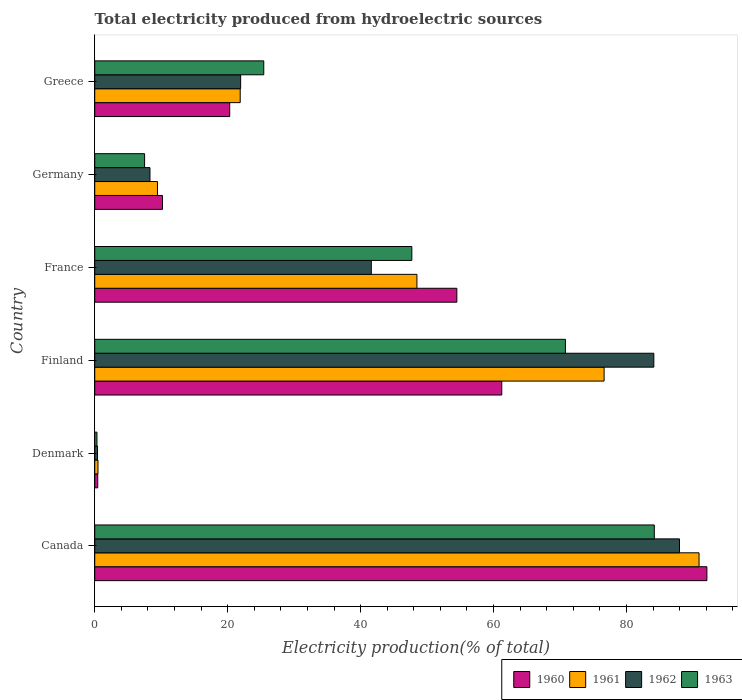How many groups of bars are there?
Keep it short and to the point. 6. Are the number of bars per tick equal to the number of legend labels?
Your answer should be compact. Yes. Are the number of bars on each tick of the Y-axis equal?
Make the answer very short. Yes. How many bars are there on the 2nd tick from the top?
Your response must be concise. 4. How many bars are there on the 1st tick from the bottom?
Give a very brief answer. 4. What is the label of the 1st group of bars from the top?
Provide a succinct answer. Greece. What is the total electricity produced in 1961 in France?
Keep it short and to the point. 48.47. Across all countries, what is the maximum total electricity produced in 1960?
Ensure brevity in your answer.  92.09. Across all countries, what is the minimum total electricity produced in 1962?
Keep it short and to the point. 0.42. In which country was the total electricity produced in 1960 maximum?
Give a very brief answer. Canada. What is the total total electricity produced in 1962 in the graph?
Keep it short and to the point. 244.36. What is the difference between the total electricity produced in 1961 in Denmark and that in Finland?
Provide a succinct answer. -76.14. What is the difference between the total electricity produced in 1962 in Greece and the total electricity produced in 1961 in Canada?
Your answer should be compact. -68.96. What is the average total electricity produced in 1962 per country?
Offer a terse response. 40.73. What is the difference between the total electricity produced in 1963 and total electricity produced in 1961 in Canada?
Your answer should be very brief. -6.73. In how many countries, is the total electricity produced in 1960 greater than 56 %?
Your answer should be compact. 2. What is the ratio of the total electricity produced in 1960 in Germany to that in Greece?
Your response must be concise. 0.5. Is the difference between the total electricity produced in 1963 in France and Germany greater than the difference between the total electricity produced in 1961 in France and Germany?
Ensure brevity in your answer.  Yes. What is the difference between the highest and the second highest total electricity produced in 1961?
Keep it short and to the point. 14.28. What is the difference between the highest and the lowest total electricity produced in 1963?
Offer a terse response. 83.84. What does the 3rd bar from the top in Finland represents?
Keep it short and to the point. 1961. What does the 4th bar from the bottom in France represents?
Keep it short and to the point. 1963. How many bars are there?
Provide a succinct answer. 24. Are all the bars in the graph horizontal?
Your response must be concise. Yes. Are the values on the major ticks of X-axis written in scientific E-notation?
Your answer should be very brief. No. Does the graph contain any zero values?
Make the answer very short. No. Does the graph contain grids?
Your answer should be very brief. No. How many legend labels are there?
Your response must be concise. 4. What is the title of the graph?
Your answer should be very brief. Total electricity produced from hydroelectric sources. What is the label or title of the X-axis?
Your answer should be very brief. Electricity production(% of total). What is the label or title of the Y-axis?
Offer a very short reply. Country. What is the Electricity production(% of total) of 1960 in Canada?
Offer a terse response. 92.09. What is the Electricity production(% of total) of 1961 in Canada?
Ensure brevity in your answer.  90.91. What is the Electricity production(% of total) in 1962 in Canada?
Keep it short and to the point. 87.97. What is the Electricity production(% of total) in 1963 in Canada?
Give a very brief answer. 84.18. What is the Electricity production(% of total) in 1960 in Denmark?
Keep it short and to the point. 0.45. What is the Electricity production(% of total) in 1961 in Denmark?
Ensure brevity in your answer.  0.49. What is the Electricity production(% of total) of 1962 in Denmark?
Ensure brevity in your answer.  0.42. What is the Electricity production(% of total) of 1963 in Denmark?
Provide a succinct answer. 0.33. What is the Electricity production(% of total) of 1960 in Finland?
Make the answer very short. 61.23. What is the Electricity production(% of total) in 1961 in Finland?
Your answer should be compact. 76.63. What is the Electricity production(% of total) in 1962 in Finland?
Keep it short and to the point. 84.11. What is the Electricity production(% of total) in 1963 in Finland?
Make the answer very short. 70.81. What is the Electricity production(% of total) in 1960 in France?
Offer a very short reply. 54.47. What is the Electricity production(% of total) in 1961 in France?
Offer a terse response. 48.47. What is the Electricity production(% of total) in 1962 in France?
Your answer should be compact. 41.61. What is the Electricity production(% of total) of 1963 in France?
Your answer should be very brief. 47.7. What is the Electricity production(% of total) in 1960 in Germany?
Give a very brief answer. 10.19. What is the Electricity production(% of total) in 1961 in Germany?
Offer a terse response. 9.44. What is the Electricity production(% of total) in 1962 in Germany?
Keep it short and to the point. 8.31. What is the Electricity production(% of total) in 1963 in Germany?
Your answer should be very brief. 7.5. What is the Electricity production(% of total) in 1960 in Greece?
Offer a terse response. 20.31. What is the Electricity production(% of total) of 1961 in Greece?
Provide a short and direct response. 21.88. What is the Electricity production(% of total) of 1962 in Greece?
Provide a short and direct response. 21.95. What is the Electricity production(% of total) in 1963 in Greece?
Provide a short and direct response. 25.43. Across all countries, what is the maximum Electricity production(% of total) of 1960?
Your answer should be very brief. 92.09. Across all countries, what is the maximum Electricity production(% of total) of 1961?
Provide a short and direct response. 90.91. Across all countries, what is the maximum Electricity production(% of total) of 1962?
Keep it short and to the point. 87.97. Across all countries, what is the maximum Electricity production(% of total) in 1963?
Provide a short and direct response. 84.18. Across all countries, what is the minimum Electricity production(% of total) in 1960?
Your answer should be very brief. 0.45. Across all countries, what is the minimum Electricity production(% of total) of 1961?
Offer a terse response. 0.49. Across all countries, what is the minimum Electricity production(% of total) in 1962?
Offer a terse response. 0.42. Across all countries, what is the minimum Electricity production(% of total) of 1963?
Your answer should be compact. 0.33. What is the total Electricity production(% of total) of 1960 in the graph?
Offer a very short reply. 238.74. What is the total Electricity production(% of total) in 1961 in the graph?
Give a very brief answer. 247.82. What is the total Electricity production(% of total) in 1962 in the graph?
Give a very brief answer. 244.36. What is the total Electricity production(% of total) in 1963 in the graph?
Offer a terse response. 235.95. What is the difference between the Electricity production(% of total) of 1960 in Canada and that in Denmark?
Ensure brevity in your answer.  91.64. What is the difference between the Electricity production(% of total) in 1961 in Canada and that in Denmark?
Make the answer very short. 90.42. What is the difference between the Electricity production(% of total) of 1962 in Canada and that in Denmark?
Make the answer very short. 87.55. What is the difference between the Electricity production(% of total) in 1963 in Canada and that in Denmark?
Your response must be concise. 83.84. What is the difference between the Electricity production(% of total) of 1960 in Canada and that in Finland?
Provide a short and direct response. 30.86. What is the difference between the Electricity production(% of total) of 1961 in Canada and that in Finland?
Your answer should be compact. 14.28. What is the difference between the Electricity production(% of total) in 1962 in Canada and that in Finland?
Keep it short and to the point. 3.86. What is the difference between the Electricity production(% of total) of 1963 in Canada and that in Finland?
Offer a very short reply. 13.37. What is the difference between the Electricity production(% of total) of 1960 in Canada and that in France?
Your response must be concise. 37.62. What is the difference between the Electricity production(% of total) in 1961 in Canada and that in France?
Make the answer very short. 42.44. What is the difference between the Electricity production(% of total) in 1962 in Canada and that in France?
Provide a short and direct response. 46.36. What is the difference between the Electricity production(% of total) of 1963 in Canada and that in France?
Make the answer very short. 36.48. What is the difference between the Electricity production(% of total) of 1960 in Canada and that in Germany?
Keep it short and to the point. 81.9. What is the difference between the Electricity production(% of total) of 1961 in Canada and that in Germany?
Keep it short and to the point. 81.47. What is the difference between the Electricity production(% of total) in 1962 in Canada and that in Germany?
Keep it short and to the point. 79.66. What is the difference between the Electricity production(% of total) of 1963 in Canada and that in Germany?
Your answer should be very brief. 76.68. What is the difference between the Electricity production(% of total) in 1960 in Canada and that in Greece?
Give a very brief answer. 71.78. What is the difference between the Electricity production(% of total) in 1961 in Canada and that in Greece?
Provide a short and direct response. 69.03. What is the difference between the Electricity production(% of total) in 1962 in Canada and that in Greece?
Give a very brief answer. 66.02. What is the difference between the Electricity production(% of total) in 1963 in Canada and that in Greece?
Offer a terse response. 58.75. What is the difference between the Electricity production(% of total) of 1960 in Denmark and that in Finland?
Offer a terse response. -60.78. What is the difference between the Electricity production(% of total) of 1961 in Denmark and that in Finland?
Give a very brief answer. -76.14. What is the difference between the Electricity production(% of total) of 1962 in Denmark and that in Finland?
Provide a short and direct response. -83.69. What is the difference between the Electricity production(% of total) of 1963 in Denmark and that in Finland?
Your answer should be very brief. -70.47. What is the difference between the Electricity production(% of total) in 1960 in Denmark and that in France?
Make the answer very short. -54.02. What is the difference between the Electricity production(% of total) in 1961 in Denmark and that in France?
Ensure brevity in your answer.  -47.98. What is the difference between the Electricity production(% of total) of 1962 in Denmark and that in France?
Offer a very short reply. -41.18. What is the difference between the Electricity production(% of total) in 1963 in Denmark and that in France?
Provide a succinct answer. -47.37. What is the difference between the Electricity production(% of total) in 1960 in Denmark and that in Germany?
Your response must be concise. -9.74. What is the difference between the Electricity production(% of total) in 1961 in Denmark and that in Germany?
Offer a terse response. -8.95. What is the difference between the Electricity production(% of total) of 1962 in Denmark and that in Germany?
Provide a succinct answer. -7.89. What is the difference between the Electricity production(% of total) of 1963 in Denmark and that in Germany?
Provide a short and direct response. -7.17. What is the difference between the Electricity production(% of total) of 1960 in Denmark and that in Greece?
Provide a succinct answer. -19.85. What is the difference between the Electricity production(% of total) of 1961 in Denmark and that in Greece?
Offer a terse response. -21.39. What is the difference between the Electricity production(% of total) in 1962 in Denmark and that in Greece?
Ensure brevity in your answer.  -21.53. What is the difference between the Electricity production(% of total) in 1963 in Denmark and that in Greece?
Offer a terse response. -25.09. What is the difference between the Electricity production(% of total) of 1960 in Finland and that in France?
Your response must be concise. 6.76. What is the difference between the Electricity production(% of total) of 1961 in Finland and that in France?
Your answer should be compact. 28.16. What is the difference between the Electricity production(% of total) of 1962 in Finland and that in France?
Offer a very short reply. 42.5. What is the difference between the Electricity production(% of total) of 1963 in Finland and that in France?
Offer a very short reply. 23.11. What is the difference between the Electricity production(% of total) in 1960 in Finland and that in Germany?
Ensure brevity in your answer.  51.04. What is the difference between the Electricity production(% of total) in 1961 in Finland and that in Germany?
Provide a succinct answer. 67.19. What is the difference between the Electricity production(% of total) of 1962 in Finland and that in Germany?
Provide a short and direct response. 75.8. What is the difference between the Electricity production(% of total) in 1963 in Finland and that in Germany?
Your response must be concise. 63.31. What is the difference between the Electricity production(% of total) of 1960 in Finland and that in Greece?
Provide a succinct answer. 40.93. What is the difference between the Electricity production(% of total) in 1961 in Finland and that in Greece?
Offer a very short reply. 54.75. What is the difference between the Electricity production(% of total) of 1962 in Finland and that in Greece?
Offer a very short reply. 62.16. What is the difference between the Electricity production(% of total) in 1963 in Finland and that in Greece?
Your answer should be very brief. 45.38. What is the difference between the Electricity production(% of total) in 1960 in France and that in Germany?
Offer a very short reply. 44.28. What is the difference between the Electricity production(% of total) in 1961 in France and that in Germany?
Your answer should be very brief. 39.03. What is the difference between the Electricity production(% of total) of 1962 in France and that in Germany?
Give a very brief answer. 33.3. What is the difference between the Electricity production(% of total) in 1963 in France and that in Germany?
Your response must be concise. 40.2. What is the difference between the Electricity production(% of total) in 1960 in France and that in Greece?
Give a very brief answer. 34.17. What is the difference between the Electricity production(% of total) in 1961 in France and that in Greece?
Provide a succinct answer. 26.58. What is the difference between the Electricity production(% of total) in 1962 in France and that in Greece?
Offer a very short reply. 19.66. What is the difference between the Electricity production(% of total) of 1963 in France and that in Greece?
Ensure brevity in your answer.  22.27. What is the difference between the Electricity production(% of total) of 1960 in Germany and that in Greece?
Give a very brief answer. -10.11. What is the difference between the Electricity production(% of total) in 1961 in Germany and that in Greece?
Ensure brevity in your answer.  -12.45. What is the difference between the Electricity production(% of total) in 1962 in Germany and that in Greece?
Your answer should be very brief. -13.64. What is the difference between the Electricity production(% of total) of 1963 in Germany and that in Greece?
Make the answer very short. -17.93. What is the difference between the Electricity production(% of total) of 1960 in Canada and the Electricity production(% of total) of 1961 in Denmark?
Your response must be concise. 91.6. What is the difference between the Electricity production(% of total) of 1960 in Canada and the Electricity production(% of total) of 1962 in Denmark?
Offer a very short reply. 91.67. What is the difference between the Electricity production(% of total) of 1960 in Canada and the Electricity production(% of total) of 1963 in Denmark?
Your answer should be compact. 91.75. What is the difference between the Electricity production(% of total) of 1961 in Canada and the Electricity production(% of total) of 1962 in Denmark?
Offer a very short reply. 90.49. What is the difference between the Electricity production(% of total) of 1961 in Canada and the Electricity production(% of total) of 1963 in Denmark?
Ensure brevity in your answer.  90.58. What is the difference between the Electricity production(% of total) in 1962 in Canada and the Electricity production(% of total) in 1963 in Denmark?
Offer a very short reply. 87.63. What is the difference between the Electricity production(% of total) of 1960 in Canada and the Electricity production(% of total) of 1961 in Finland?
Offer a very short reply. 15.46. What is the difference between the Electricity production(% of total) in 1960 in Canada and the Electricity production(% of total) in 1962 in Finland?
Make the answer very short. 7.98. What is the difference between the Electricity production(% of total) of 1960 in Canada and the Electricity production(% of total) of 1963 in Finland?
Provide a short and direct response. 21.28. What is the difference between the Electricity production(% of total) of 1961 in Canada and the Electricity production(% of total) of 1962 in Finland?
Provide a short and direct response. 6.8. What is the difference between the Electricity production(% of total) of 1961 in Canada and the Electricity production(% of total) of 1963 in Finland?
Your answer should be very brief. 20.1. What is the difference between the Electricity production(% of total) in 1962 in Canada and the Electricity production(% of total) in 1963 in Finland?
Offer a very short reply. 17.16. What is the difference between the Electricity production(% of total) in 1960 in Canada and the Electricity production(% of total) in 1961 in France?
Your answer should be very brief. 43.62. What is the difference between the Electricity production(% of total) of 1960 in Canada and the Electricity production(% of total) of 1962 in France?
Provide a short and direct response. 50.48. What is the difference between the Electricity production(% of total) in 1960 in Canada and the Electricity production(% of total) in 1963 in France?
Provide a succinct answer. 44.39. What is the difference between the Electricity production(% of total) in 1961 in Canada and the Electricity production(% of total) in 1962 in France?
Offer a very short reply. 49.3. What is the difference between the Electricity production(% of total) of 1961 in Canada and the Electricity production(% of total) of 1963 in France?
Offer a terse response. 43.21. What is the difference between the Electricity production(% of total) in 1962 in Canada and the Electricity production(% of total) in 1963 in France?
Ensure brevity in your answer.  40.27. What is the difference between the Electricity production(% of total) of 1960 in Canada and the Electricity production(% of total) of 1961 in Germany?
Provide a short and direct response. 82.65. What is the difference between the Electricity production(% of total) in 1960 in Canada and the Electricity production(% of total) in 1962 in Germany?
Offer a very short reply. 83.78. What is the difference between the Electricity production(% of total) of 1960 in Canada and the Electricity production(% of total) of 1963 in Germany?
Make the answer very short. 84.59. What is the difference between the Electricity production(% of total) of 1961 in Canada and the Electricity production(% of total) of 1962 in Germany?
Your response must be concise. 82.6. What is the difference between the Electricity production(% of total) of 1961 in Canada and the Electricity production(% of total) of 1963 in Germany?
Offer a very short reply. 83.41. What is the difference between the Electricity production(% of total) of 1962 in Canada and the Electricity production(% of total) of 1963 in Germany?
Offer a very short reply. 80.47. What is the difference between the Electricity production(% of total) of 1960 in Canada and the Electricity production(% of total) of 1961 in Greece?
Make the answer very short. 70.21. What is the difference between the Electricity production(% of total) of 1960 in Canada and the Electricity production(% of total) of 1962 in Greece?
Your answer should be very brief. 70.14. What is the difference between the Electricity production(% of total) in 1960 in Canada and the Electricity production(% of total) in 1963 in Greece?
Give a very brief answer. 66.66. What is the difference between the Electricity production(% of total) of 1961 in Canada and the Electricity production(% of total) of 1962 in Greece?
Your answer should be very brief. 68.96. What is the difference between the Electricity production(% of total) in 1961 in Canada and the Electricity production(% of total) in 1963 in Greece?
Provide a succinct answer. 65.48. What is the difference between the Electricity production(% of total) in 1962 in Canada and the Electricity production(% of total) in 1963 in Greece?
Provide a succinct answer. 62.54. What is the difference between the Electricity production(% of total) in 1960 in Denmark and the Electricity production(% of total) in 1961 in Finland?
Keep it short and to the point. -76.18. What is the difference between the Electricity production(% of total) of 1960 in Denmark and the Electricity production(% of total) of 1962 in Finland?
Give a very brief answer. -83.66. What is the difference between the Electricity production(% of total) of 1960 in Denmark and the Electricity production(% of total) of 1963 in Finland?
Ensure brevity in your answer.  -70.36. What is the difference between the Electricity production(% of total) in 1961 in Denmark and the Electricity production(% of total) in 1962 in Finland?
Your response must be concise. -83.62. What is the difference between the Electricity production(% of total) in 1961 in Denmark and the Electricity production(% of total) in 1963 in Finland?
Keep it short and to the point. -70.32. What is the difference between the Electricity production(% of total) in 1962 in Denmark and the Electricity production(% of total) in 1963 in Finland?
Ensure brevity in your answer.  -70.39. What is the difference between the Electricity production(% of total) in 1960 in Denmark and the Electricity production(% of total) in 1961 in France?
Your response must be concise. -48.02. What is the difference between the Electricity production(% of total) of 1960 in Denmark and the Electricity production(% of total) of 1962 in France?
Your answer should be very brief. -41.15. What is the difference between the Electricity production(% of total) of 1960 in Denmark and the Electricity production(% of total) of 1963 in France?
Ensure brevity in your answer.  -47.25. What is the difference between the Electricity production(% of total) in 1961 in Denmark and the Electricity production(% of total) in 1962 in France?
Provide a short and direct response. -41.12. What is the difference between the Electricity production(% of total) in 1961 in Denmark and the Electricity production(% of total) in 1963 in France?
Keep it short and to the point. -47.21. What is the difference between the Electricity production(% of total) of 1962 in Denmark and the Electricity production(% of total) of 1963 in France?
Make the answer very short. -47.28. What is the difference between the Electricity production(% of total) in 1960 in Denmark and the Electricity production(% of total) in 1961 in Germany?
Provide a succinct answer. -8.99. What is the difference between the Electricity production(% of total) in 1960 in Denmark and the Electricity production(% of total) in 1962 in Germany?
Keep it short and to the point. -7.86. What is the difference between the Electricity production(% of total) of 1960 in Denmark and the Electricity production(% of total) of 1963 in Germany?
Give a very brief answer. -7.05. What is the difference between the Electricity production(% of total) in 1961 in Denmark and the Electricity production(% of total) in 1962 in Germany?
Ensure brevity in your answer.  -7.82. What is the difference between the Electricity production(% of total) in 1961 in Denmark and the Electricity production(% of total) in 1963 in Germany?
Provide a short and direct response. -7.01. What is the difference between the Electricity production(% of total) in 1962 in Denmark and the Electricity production(% of total) in 1963 in Germany?
Provide a short and direct response. -7.08. What is the difference between the Electricity production(% of total) of 1960 in Denmark and the Electricity production(% of total) of 1961 in Greece?
Provide a short and direct response. -21.43. What is the difference between the Electricity production(% of total) in 1960 in Denmark and the Electricity production(% of total) in 1962 in Greece?
Offer a terse response. -21.5. What is the difference between the Electricity production(% of total) in 1960 in Denmark and the Electricity production(% of total) in 1963 in Greece?
Provide a succinct answer. -24.98. What is the difference between the Electricity production(% of total) in 1961 in Denmark and the Electricity production(% of total) in 1962 in Greece?
Offer a very short reply. -21.46. What is the difference between the Electricity production(% of total) in 1961 in Denmark and the Electricity production(% of total) in 1963 in Greece?
Your answer should be very brief. -24.94. What is the difference between the Electricity production(% of total) in 1962 in Denmark and the Electricity production(% of total) in 1963 in Greece?
Offer a terse response. -25.01. What is the difference between the Electricity production(% of total) in 1960 in Finland and the Electricity production(% of total) in 1961 in France?
Provide a short and direct response. 12.76. What is the difference between the Electricity production(% of total) in 1960 in Finland and the Electricity production(% of total) in 1962 in France?
Keep it short and to the point. 19.63. What is the difference between the Electricity production(% of total) in 1960 in Finland and the Electricity production(% of total) in 1963 in France?
Offer a very short reply. 13.53. What is the difference between the Electricity production(% of total) in 1961 in Finland and the Electricity production(% of total) in 1962 in France?
Offer a terse response. 35.02. What is the difference between the Electricity production(% of total) of 1961 in Finland and the Electricity production(% of total) of 1963 in France?
Make the answer very short. 28.93. What is the difference between the Electricity production(% of total) in 1962 in Finland and the Electricity production(% of total) in 1963 in France?
Provide a short and direct response. 36.41. What is the difference between the Electricity production(% of total) in 1960 in Finland and the Electricity production(% of total) in 1961 in Germany?
Your answer should be very brief. 51.8. What is the difference between the Electricity production(% of total) in 1960 in Finland and the Electricity production(% of total) in 1962 in Germany?
Your response must be concise. 52.92. What is the difference between the Electricity production(% of total) in 1960 in Finland and the Electricity production(% of total) in 1963 in Germany?
Keep it short and to the point. 53.73. What is the difference between the Electricity production(% of total) in 1961 in Finland and the Electricity production(% of total) in 1962 in Germany?
Keep it short and to the point. 68.32. What is the difference between the Electricity production(% of total) of 1961 in Finland and the Electricity production(% of total) of 1963 in Germany?
Your answer should be very brief. 69.13. What is the difference between the Electricity production(% of total) of 1962 in Finland and the Electricity production(% of total) of 1963 in Germany?
Offer a terse response. 76.61. What is the difference between the Electricity production(% of total) of 1960 in Finland and the Electricity production(% of total) of 1961 in Greece?
Offer a terse response. 39.35. What is the difference between the Electricity production(% of total) in 1960 in Finland and the Electricity production(% of total) in 1962 in Greece?
Keep it short and to the point. 39.28. What is the difference between the Electricity production(% of total) of 1960 in Finland and the Electricity production(% of total) of 1963 in Greece?
Keep it short and to the point. 35.8. What is the difference between the Electricity production(% of total) in 1961 in Finland and the Electricity production(% of total) in 1962 in Greece?
Your answer should be very brief. 54.68. What is the difference between the Electricity production(% of total) of 1961 in Finland and the Electricity production(% of total) of 1963 in Greece?
Your answer should be compact. 51.2. What is the difference between the Electricity production(% of total) in 1962 in Finland and the Electricity production(% of total) in 1963 in Greece?
Provide a succinct answer. 58.68. What is the difference between the Electricity production(% of total) of 1960 in France and the Electricity production(% of total) of 1961 in Germany?
Provide a succinct answer. 45.04. What is the difference between the Electricity production(% of total) in 1960 in France and the Electricity production(% of total) in 1962 in Germany?
Your answer should be compact. 46.16. What is the difference between the Electricity production(% of total) in 1960 in France and the Electricity production(% of total) in 1963 in Germany?
Your answer should be very brief. 46.97. What is the difference between the Electricity production(% of total) of 1961 in France and the Electricity production(% of total) of 1962 in Germany?
Ensure brevity in your answer.  40.16. What is the difference between the Electricity production(% of total) in 1961 in France and the Electricity production(% of total) in 1963 in Germany?
Ensure brevity in your answer.  40.97. What is the difference between the Electricity production(% of total) of 1962 in France and the Electricity production(% of total) of 1963 in Germany?
Offer a very short reply. 34.11. What is the difference between the Electricity production(% of total) of 1960 in France and the Electricity production(% of total) of 1961 in Greece?
Provide a short and direct response. 32.59. What is the difference between the Electricity production(% of total) in 1960 in France and the Electricity production(% of total) in 1962 in Greece?
Offer a terse response. 32.52. What is the difference between the Electricity production(% of total) in 1960 in France and the Electricity production(% of total) in 1963 in Greece?
Offer a terse response. 29.05. What is the difference between the Electricity production(% of total) of 1961 in France and the Electricity production(% of total) of 1962 in Greece?
Keep it short and to the point. 26.52. What is the difference between the Electricity production(% of total) in 1961 in France and the Electricity production(% of total) in 1963 in Greece?
Make the answer very short. 23.04. What is the difference between the Electricity production(% of total) of 1962 in France and the Electricity production(% of total) of 1963 in Greece?
Offer a very short reply. 16.18. What is the difference between the Electricity production(% of total) in 1960 in Germany and the Electricity production(% of total) in 1961 in Greece?
Your answer should be very brief. -11.69. What is the difference between the Electricity production(% of total) in 1960 in Germany and the Electricity production(% of total) in 1962 in Greece?
Your response must be concise. -11.76. What is the difference between the Electricity production(% of total) of 1960 in Germany and the Electricity production(% of total) of 1963 in Greece?
Your response must be concise. -15.24. What is the difference between the Electricity production(% of total) in 1961 in Germany and the Electricity production(% of total) in 1962 in Greece?
Offer a very short reply. -12.51. What is the difference between the Electricity production(% of total) of 1961 in Germany and the Electricity production(% of total) of 1963 in Greece?
Your answer should be very brief. -15.99. What is the difference between the Electricity production(% of total) of 1962 in Germany and the Electricity production(% of total) of 1963 in Greece?
Your answer should be very brief. -17.12. What is the average Electricity production(% of total) in 1960 per country?
Make the answer very short. 39.79. What is the average Electricity production(% of total) in 1961 per country?
Provide a short and direct response. 41.3. What is the average Electricity production(% of total) of 1962 per country?
Provide a succinct answer. 40.73. What is the average Electricity production(% of total) of 1963 per country?
Offer a terse response. 39.33. What is the difference between the Electricity production(% of total) of 1960 and Electricity production(% of total) of 1961 in Canada?
Provide a succinct answer. 1.18. What is the difference between the Electricity production(% of total) of 1960 and Electricity production(% of total) of 1962 in Canada?
Offer a terse response. 4.12. What is the difference between the Electricity production(% of total) in 1960 and Electricity production(% of total) in 1963 in Canada?
Make the answer very short. 7.91. What is the difference between the Electricity production(% of total) in 1961 and Electricity production(% of total) in 1962 in Canada?
Ensure brevity in your answer.  2.94. What is the difference between the Electricity production(% of total) in 1961 and Electricity production(% of total) in 1963 in Canada?
Your answer should be compact. 6.73. What is the difference between the Electricity production(% of total) in 1962 and Electricity production(% of total) in 1963 in Canada?
Ensure brevity in your answer.  3.79. What is the difference between the Electricity production(% of total) of 1960 and Electricity production(% of total) of 1961 in Denmark?
Give a very brief answer. -0.04. What is the difference between the Electricity production(% of total) in 1960 and Electricity production(% of total) in 1962 in Denmark?
Ensure brevity in your answer.  0.03. What is the difference between the Electricity production(% of total) in 1960 and Electricity production(% of total) in 1963 in Denmark?
Offer a very short reply. 0.12. What is the difference between the Electricity production(% of total) in 1961 and Electricity production(% of total) in 1962 in Denmark?
Give a very brief answer. 0.07. What is the difference between the Electricity production(% of total) of 1961 and Electricity production(% of total) of 1963 in Denmark?
Offer a very short reply. 0.15. What is the difference between the Electricity production(% of total) of 1962 and Electricity production(% of total) of 1963 in Denmark?
Make the answer very short. 0.09. What is the difference between the Electricity production(% of total) in 1960 and Electricity production(% of total) in 1961 in Finland?
Ensure brevity in your answer.  -15.4. What is the difference between the Electricity production(% of total) of 1960 and Electricity production(% of total) of 1962 in Finland?
Your answer should be very brief. -22.88. What is the difference between the Electricity production(% of total) of 1960 and Electricity production(% of total) of 1963 in Finland?
Ensure brevity in your answer.  -9.58. What is the difference between the Electricity production(% of total) of 1961 and Electricity production(% of total) of 1962 in Finland?
Offer a very short reply. -7.48. What is the difference between the Electricity production(% of total) in 1961 and Electricity production(% of total) in 1963 in Finland?
Give a very brief answer. 5.82. What is the difference between the Electricity production(% of total) of 1962 and Electricity production(% of total) of 1963 in Finland?
Offer a very short reply. 13.3. What is the difference between the Electricity production(% of total) in 1960 and Electricity production(% of total) in 1961 in France?
Offer a terse response. 6.01. What is the difference between the Electricity production(% of total) in 1960 and Electricity production(% of total) in 1962 in France?
Provide a short and direct response. 12.87. What is the difference between the Electricity production(% of total) in 1960 and Electricity production(% of total) in 1963 in France?
Your response must be concise. 6.77. What is the difference between the Electricity production(% of total) of 1961 and Electricity production(% of total) of 1962 in France?
Ensure brevity in your answer.  6.86. What is the difference between the Electricity production(% of total) of 1961 and Electricity production(% of total) of 1963 in France?
Keep it short and to the point. 0.77. What is the difference between the Electricity production(% of total) in 1962 and Electricity production(% of total) in 1963 in France?
Give a very brief answer. -6.1. What is the difference between the Electricity production(% of total) of 1960 and Electricity production(% of total) of 1961 in Germany?
Your answer should be very brief. 0.76. What is the difference between the Electricity production(% of total) in 1960 and Electricity production(% of total) in 1962 in Germany?
Offer a terse response. 1.88. What is the difference between the Electricity production(% of total) in 1960 and Electricity production(% of total) in 1963 in Germany?
Keep it short and to the point. 2.69. What is the difference between the Electricity production(% of total) of 1961 and Electricity production(% of total) of 1962 in Germany?
Give a very brief answer. 1.13. What is the difference between the Electricity production(% of total) of 1961 and Electricity production(% of total) of 1963 in Germany?
Make the answer very short. 1.94. What is the difference between the Electricity production(% of total) in 1962 and Electricity production(% of total) in 1963 in Germany?
Provide a succinct answer. 0.81. What is the difference between the Electricity production(% of total) of 1960 and Electricity production(% of total) of 1961 in Greece?
Give a very brief answer. -1.58. What is the difference between the Electricity production(% of total) of 1960 and Electricity production(% of total) of 1962 in Greece?
Keep it short and to the point. -1.64. What is the difference between the Electricity production(% of total) in 1960 and Electricity production(% of total) in 1963 in Greece?
Your response must be concise. -5.12. What is the difference between the Electricity production(% of total) of 1961 and Electricity production(% of total) of 1962 in Greece?
Give a very brief answer. -0.07. What is the difference between the Electricity production(% of total) of 1961 and Electricity production(% of total) of 1963 in Greece?
Provide a succinct answer. -3.54. What is the difference between the Electricity production(% of total) in 1962 and Electricity production(% of total) in 1963 in Greece?
Keep it short and to the point. -3.48. What is the ratio of the Electricity production(% of total) in 1960 in Canada to that in Denmark?
Provide a succinct answer. 204.07. What is the ratio of the Electricity production(% of total) in 1961 in Canada to that in Denmark?
Make the answer very short. 185.88. What is the ratio of the Electricity production(% of total) in 1962 in Canada to that in Denmark?
Offer a terse response. 208.99. What is the ratio of the Electricity production(% of total) in 1963 in Canada to that in Denmark?
Your answer should be compact. 251.69. What is the ratio of the Electricity production(% of total) of 1960 in Canada to that in Finland?
Ensure brevity in your answer.  1.5. What is the ratio of the Electricity production(% of total) in 1961 in Canada to that in Finland?
Your answer should be compact. 1.19. What is the ratio of the Electricity production(% of total) of 1962 in Canada to that in Finland?
Provide a succinct answer. 1.05. What is the ratio of the Electricity production(% of total) of 1963 in Canada to that in Finland?
Provide a short and direct response. 1.19. What is the ratio of the Electricity production(% of total) of 1960 in Canada to that in France?
Ensure brevity in your answer.  1.69. What is the ratio of the Electricity production(% of total) of 1961 in Canada to that in France?
Your response must be concise. 1.88. What is the ratio of the Electricity production(% of total) of 1962 in Canada to that in France?
Keep it short and to the point. 2.11. What is the ratio of the Electricity production(% of total) of 1963 in Canada to that in France?
Your response must be concise. 1.76. What is the ratio of the Electricity production(% of total) of 1960 in Canada to that in Germany?
Keep it short and to the point. 9.04. What is the ratio of the Electricity production(% of total) in 1961 in Canada to that in Germany?
Give a very brief answer. 9.63. What is the ratio of the Electricity production(% of total) in 1962 in Canada to that in Germany?
Keep it short and to the point. 10.59. What is the ratio of the Electricity production(% of total) of 1963 in Canada to that in Germany?
Give a very brief answer. 11.22. What is the ratio of the Electricity production(% of total) in 1960 in Canada to that in Greece?
Your answer should be very brief. 4.54. What is the ratio of the Electricity production(% of total) in 1961 in Canada to that in Greece?
Your answer should be compact. 4.15. What is the ratio of the Electricity production(% of total) in 1962 in Canada to that in Greece?
Provide a short and direct response. 4.01. What is the ratio of the Electricity production(% of total) of 1963 in Canada to that in Greece?
Your answer should be compact. 3.31. What is the ratio of the Electricity production(% of total) in 1960 in Denmark to that in Finland?
Provide a succinct answer. 0.01. What is the ratio of the Electricity production(% of total) in 1961 in Denmark to that in Finland?
Ensure brevity in your answer.  0.01. What is the ratio of the Electricity production(% of total) in 1962 in Denmark to that in Finland?
Offer a terse response. 0.01. What is the ratio of the Electricity production(% of total) in 1963 in Denmark to that in Finland?
Provide a short and direct response. 0. What is the ratio of the Electricity production(% of total) of 1960 in Denmark to that in France?
Your response must be concise. 0.01. What is the ratio of the Electricity production(% of total) of 1961 in Denmark to that in France?
Offer a terse response. 0.01. What is the ratio of the Electricity production(% of total) of 1962 in Denmark to that in France?
Offer a terse response. 0.01. What is the ratio of the Electricity production(% of total) in 1963 in Denmark to that in France?
Offer a terse response. 0.01. What is the ratio of the Electricity production(% of total) in 1960 in Denmark to that in Germany?
Make the answer very short. 0.04. What is the ratio of the Electricity production(% of total) of 1961 in Denmark to that in Germany?
Keep it short and to the point. 0.05. What is the ratio of the Electricity production(% of total) of 1962 in Denmark to that in Germany?
Provide a short and direct response. 0.05. What is the ratio of the Electricity production(% of total) in 1963 in Denmark to that in Germany?
Provide a short and direct response. 0.04. What is the ratio of the Electricity production(% of total) of 1960 in Denmark to that in Greece?
Ensure brevity in your answer.  0.02. What is the ratio of the Electricity production(% of total) in 1961 in Denmark to that in Greece?
Give a very brief answer. 0.02. What is the ratio of the Electricity production(% of total) in 1962 in Denmark to that in Greece?
Your answer should be compact. 0.02. What is the ratio of the Electricity production(% of total) of 1963 in Denmark to that in Greece?
Your answer should be compact. 0.01. What is the ratio of the Electricity production(% of total) in 1960 in Finland to that in France?
Offer a very short reply. 1.12. What is the ratio of the Electricity production(% of total) in 1961 in Finland to that in France?
Keep it short and to the point. 1.58. What is the ratio of the Electricity production(% of total) of 1962 in Finland to that in France?
Ensure brevity in your answer.  2.02. What is the ratio of the Electricity production(% of total) in 1963 in Finland to that in France?
Ensure brevity in your answer.  1.48. What is the ratio of the Electricity production(% of total) in 1960 in Finland to that in Germany?
Offer a terse response. 6.01. What is the ratio of the Electricity production(% of total) of 1961 in Finland to that in Germany?
Keep it short and to the point. 8.12. What is the ratio of the Electricity production(% of total) of 1962 in Finland to that in Germany?
Ensure brevity in your answer.  10.12. What is the ratio of the Electricity production(% of total) of 1963 in Finland to that in Germany?
Provide a succinct answer. 9.44. What is the ratio of the Electricity production(% of total) of 1960 in Finland to that in Greece?
Your response must be concise. 3.02. What is the ratio of the Electricity production(% of total) in 1961 in Finland to that in Greece?
Give a very brief answer. 3.5. What is the ratio of the Electricity production(% of total) of 1962 in Finland to that in Greece?
Keep it short and to the point. 3.83. What is the ratio of the Electricity production(% of total) in 1963 in Finland to that in Greece?
Keep it short and to the point. 2.78. What is the ratio of the Electricity production(% of total) in 1960 in France to that in Germany?
Give a very brief answer. 5.34. What is the ratio of the Electricity production(% of total) of 1961 in France to that in Germany?
Keep it short and to the point. 5.14. What is the ratio of the Electricity production(% of total) of 1962 in France to that in Germany?
Ensure brevity in your answer.  5.01. What is the ratio of the Electricity production(% of total) of 1963 in France to that in Germany?
Ensure brevity in your answer.  6.36. What is the ratio of the Electricity production(% of total) in 1960 in France to that in Greece?
Your answer should be compact. 2.68. What is the ratio of the Electricity production(% of total) in 1961 in France to that in Greece?
Your response must be concise. 2.21. What is the ratio of the Electricity production(% of total) in 1962 in France to that in Greece?
Offer a very short reply. 1.9. What is the ratio of the Electricity production(% of total) in 1963 in France to that in Greece?
Offer a very short reply. 1.88. What is the ratio of the Electricity production(% of total) of 1960 in Germany to that in Greece?
Make the answer very short. 0.5. What is the ratio of the Electricity production(% of total) of 1961 in Germany to that in Greece?
Your answer should be compact. 0.43. What is the ratio of the Electricity production(% of total) of 1962 in Germany to that in Greece?
Your response must be concise. 0.38. What is the ratio of the Electricity production(% of total) of 1963 in Germany to that in Greece?
Keep it short and to the point. 0.29. What is the difference between the highest and the second highest Electricity production(% of total) in 1960?
Offer a terse response. 30.86. What is the difference between the highest and the second highest Electricity production(% of total) of 1961?
Your answer should be very brief. 14.28. What is the difference between the highest and the second highest Electricity production(% of total) in 1962?
Your answer should be compact. 3.86. What is the difference between the highest and the second highest Electricity production(% of total) in 1963?
Offer a terse response. 13.37. What is the difference between the highest and the lowest Electricity production(% of total) in 1960?
Make the answer very short. 91.64. What is the difference between the highest and the lowest Electricity production(% of total) of 1961?
Your answer should be compact. 90.42. What is the difference between the highest and the lowest Electricity production(% of total) in 1962?
Your answer should be very brief. 87.55. What is the difference between the highest and the lowest Electricity production(% of total) of 1963?
Your answer should be compact. 83.84. 